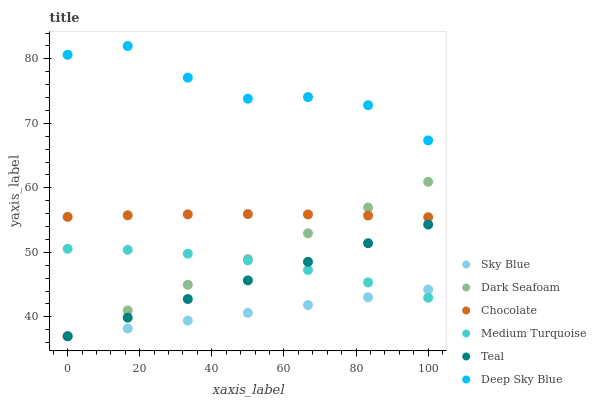Does Sky Blue have the minimum area under the curve?
Answer yes or no. Yes. Does Deep Sky Blue have the maximum area under the curve?
Answer yes or no. Yes. Does Teal have the minimum area under the curve?
Answer yes or no. No. Does Teal have the maximum area under the curve?
Answer yes or no. No. Is Teal the smoothest?
Answer yes or no. Yes. Is Deep Sky Blue the roughest?
Answer yes or no. Yes. Is Chocolate the smoothest?
Answer yes or no. No. Is Chocolate the roughest?
Answer yes or no. No. Does Teal have the lowest value?
Answer yes or no. Yes. Does Chocolate have the lowest value?
Answer yes or no. No. Does Deep Sky Blue have the highest value?
Answer yes or no. Yes. Does Teal have the highest value?
Answer yes or no. No. Is Medium Turquoise less than Deep Sky Blue?
Answer yes or no. Yes. Is Deep Sky Blue greater than Teal?
Answer yes or no. Yes. Does Teal intersect Dark Seafoam?
Answer yes or no. Yes. Is Teal less than Dark Seafoam?
Answer yes or no. No. Is Teal greater than Dark Seafoam?
Answer yes or no. No. Does Medium Turquoise intersect Deep Sky Blue?
Answer yes or no. No. 